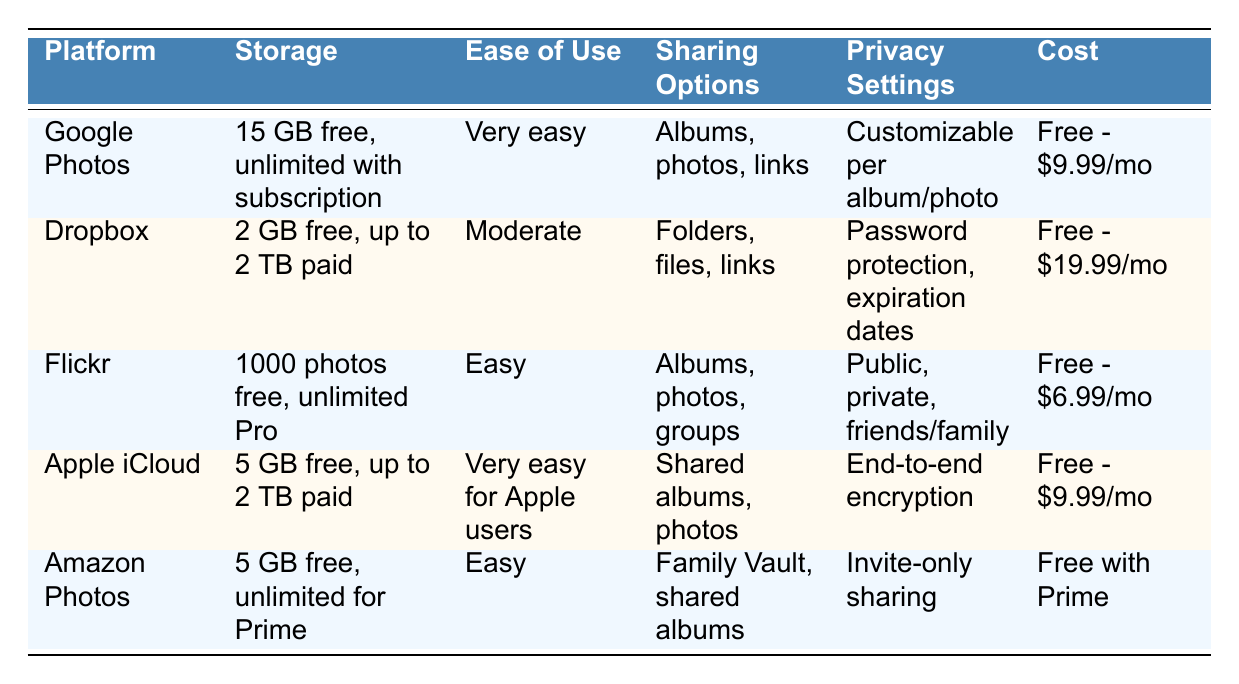What is the storage capacity of Google Photos? The table states that Google Photos offers "15 GB free, unlimited with Google One subscription" under the storage capacity column.
Answer: 15 GB free, unlimited with Google One subscription Does Dropbox support file types other than photos and videos? According to the table, Dropbox supports "All file types," indicating it can handle various formats, not limited to just photos and videos.
Answer: Yes Which platform has the highest free storage capacity? By comparing the free storage capacities listed in the table, Google Photos has 15 GB free, while Dropbox offers 2 GB, Flickr allows 1000 photos (not a direct GB measurement), Apple iCloud provides 5 GB, and Amazon Photos gives 5 GB. Hence, Google Photos has the highest free storage capacity at 15 GB.
Answer: Google Photos What are the shared options for Apple iCloud? The table indicates that the sharing options for Apple iCloud are "Shared albums, individual photos." This means that users can create and share albums or share photos individually.
Answer: Shared albums, individual photos Do any of the platforms offer facial recognition features? The table mentions "Yes" for facial recognition under Google Photos, Flickr, Apple iCloud, and Amazon Photos, while Dropbox does not have this feature. Therefore, four platforms offer facial recognition.
Answer: Yes Which platform is the most economical for basic storage? To determine this, we look at the free plans and basic options: Google Photos has basic storage for free, Dropbox is free for basic but costs $9.99/month for the premium plan, Flickr is free for basic but costs $6.99/month for Pro, Apple iCloud offers free basic but charges up to $9.99/month, and Amazon Photos is free with Prime. Since Google Photos provides the most extensive free service without requiring a subscription for basic users, it turns out to be the most economical.
Answer: Google Photos How much is the monthly cost for additional storage on Dropbox? According to the table, Dropbox charges between "$9.99-$19.99/month" for premium plans if users require extra storage.
Answer: $9.99-$19.99/month Which platform has end-to-end encryption for shared albums? The table indicates that Apple iCloud offers "End-to-end encryption for shared albums," highlighting that this feature is specifically supported by Apple iCloud.
Answer: Apple iCloud What is the sharing option offered by Amazon Photos? From the table, Amazon Photos provides "Family Vault, shared albums," showing the variety of options for sharing photos with family members.
Answer: Family Vault, shared albums 